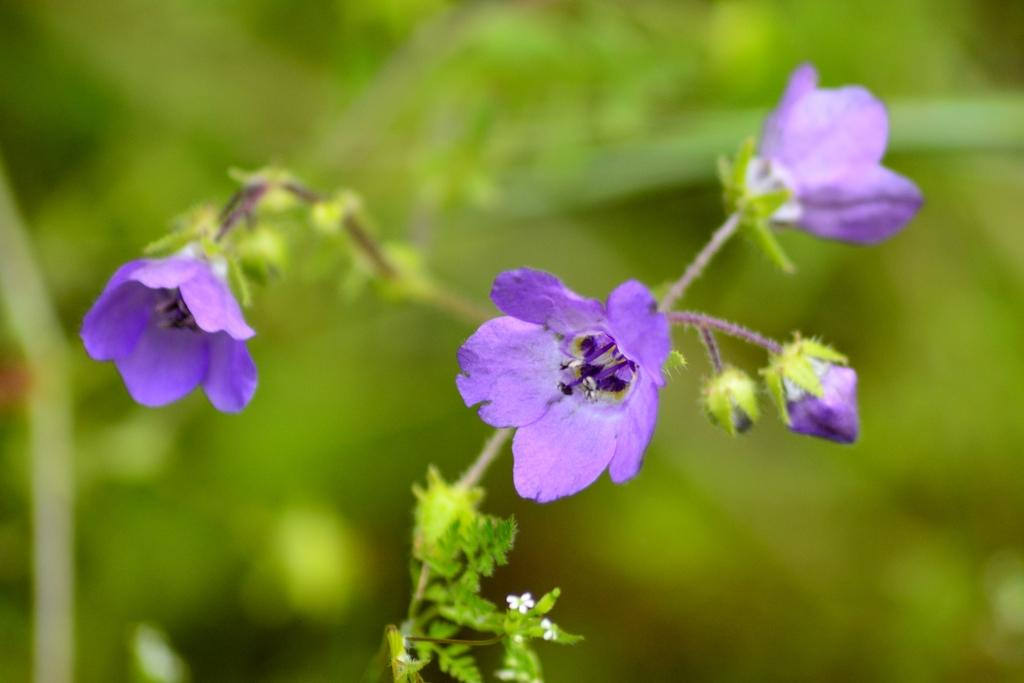What is present in the image? There is a plant in the image. Can you describe the plant in more detail? The plant has buds and flowers. What color are the flowers? The flowers are violet in color. What can be seen in the background of the image? The background of the image is green. How is the background of the image depicted? The image is blurred in the background. How many brothers are depicted in the image? There are no brothers present in the image; it features a plant with buds and flowers. What type of quilt is covering the plant in the image? There is no quilt present in the image; it is a plant with buds and flowers. 